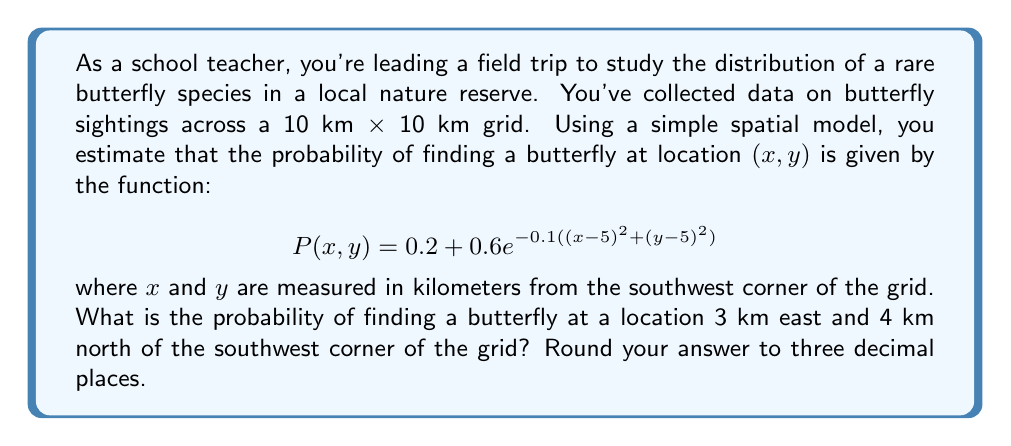Give your solution to this math problem. To solve this problem, we need to follow these steps:

1. Identify the coordinates $(x, y)$ for the given location:
   - 3 km east corresponds to $x = 3$
   - 4 km north corresponds to $y = 4$

2. Substitute these values into the given probability function:

   $$P(x, y) = 0.2 + 0.6e^{-0.1((x-5)^2 + (y-5)^2)}$$

3. Calculate the expression inside the exponential function:
   $$(x-5)^2 + (y-5)^2 = (3-5)^2 + (4-5)^2 = (-2)^2 + (-1)^2 = 4 + 1 = 5$$

4. Simplify the exponential term:
   $$e^{-0.1(5)} = e^{-0.5}$$

5. Calculate the final probability:
   $$P(3, 4) = 0.2 + 0.6e^{-0.5}$$

6. Evaluate this expression:
   $$P(3, 4) = 0.2 + 0.6 \times 0.6065 = 0.2 + 0.3639 = 0.5639$$

7. Round the result to three decimal places:
   $$P(3, 4) \approx 0.564$$

This spatial model shows that the probability of finding a butterfly decreases as we move away from the center of the grid (5, 5), with the highest probability at the center and a minimum probability of 0.2 throughout the grid.
Answer: 0.564 